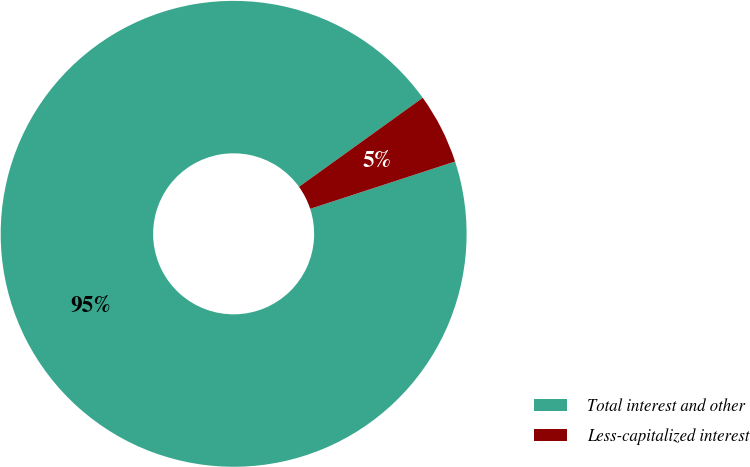Convert chart to OTSL. <chart><loc_0><loc_0><loc_500><loc_500><pie_chart><fcel>Total interest and other<fcel>Less-capitalized interest<nl><fcel>95.1%<fcel>4.9%<nl></chart> 